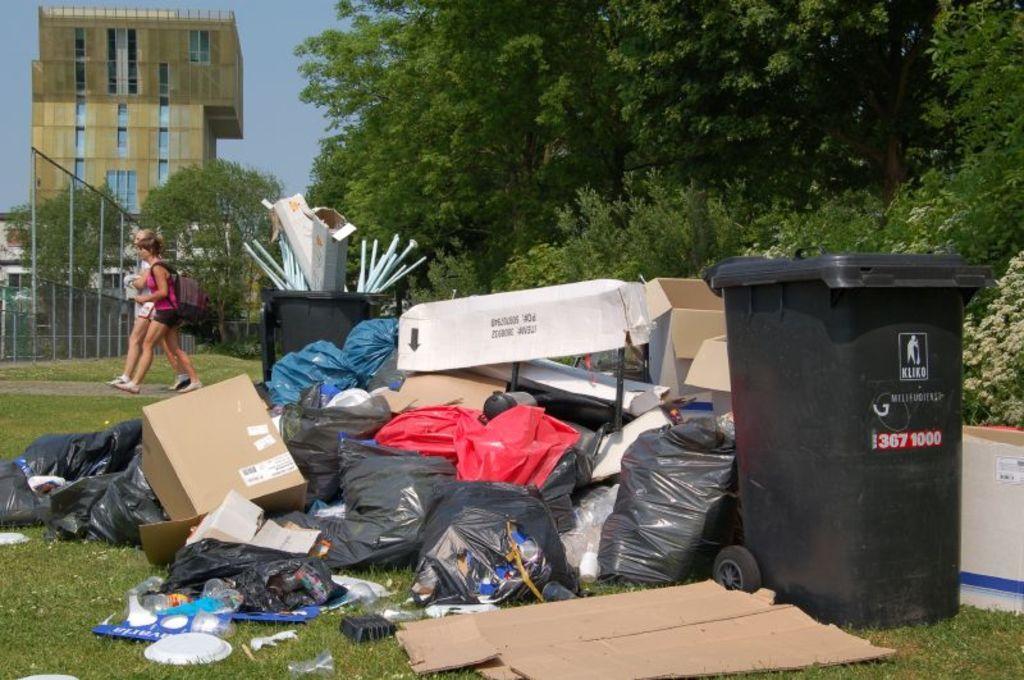Could you give a brief overview of what you see in this image? In this image, there are a few people, buildings, trees, plants. We can see the ground with some grass. We can also see some black colored covers. We can also see the sky. We can also see some trash bins. 